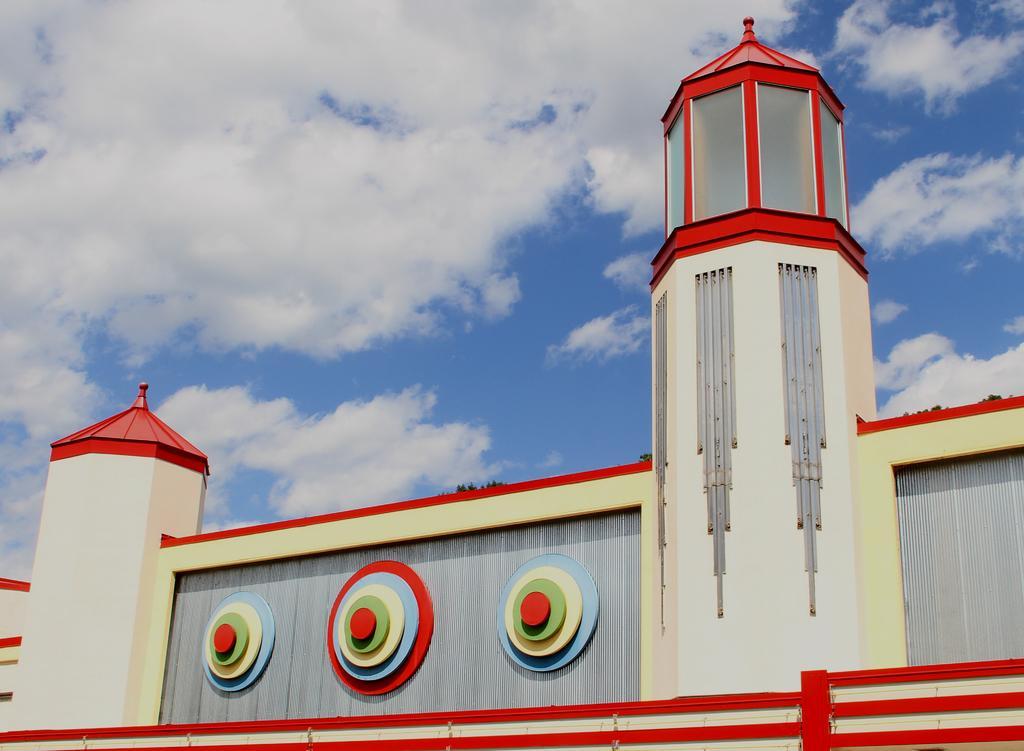Describe this image in one or two sentences. In this image we can see a building, trees and sky with clouds in the background. 